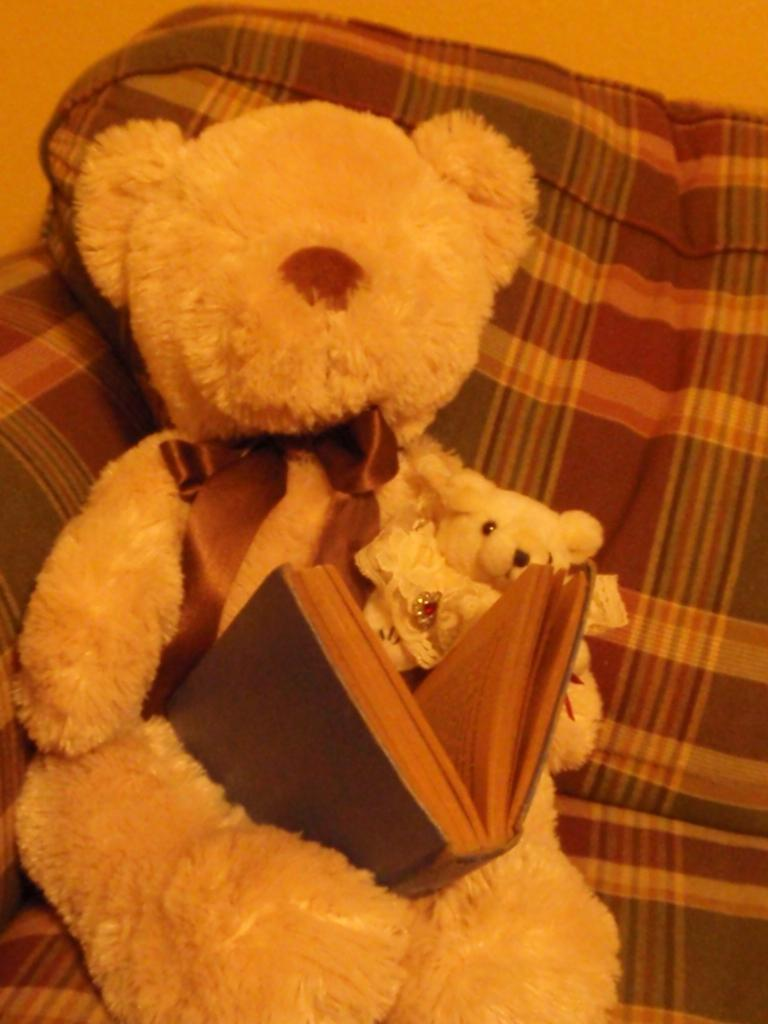What type of toy is present in the image? There is a soft toy in the image, which resembles a teddy bear. What is placed on the soft toy? There is a book on the soft toy. What type of furniture is visible in the image? There is a couch in the image. What type of monkey can be seen playing with the soft toy in the image? There is no monkey present in the image. 